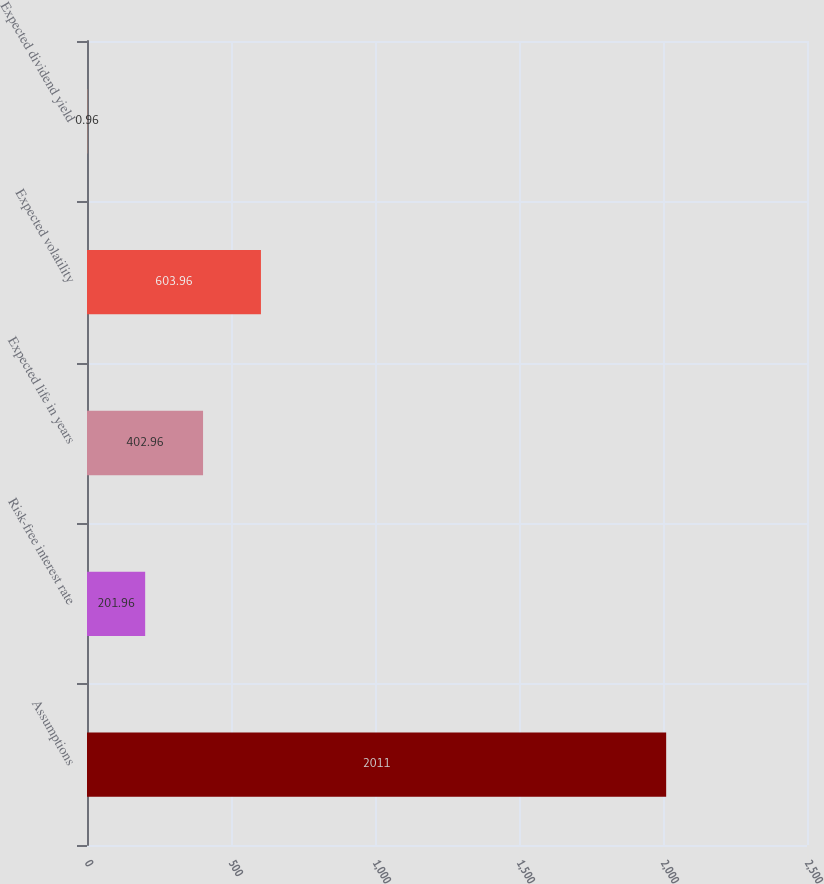<chart> <loc_0><loc_0><loc_500><loc_500><bar_chart><fcel>Assumptions<fcel>Risk-free interest rate<fcel>Expected life in years<fcel>Expected volatility<fcel>Expected dividend yield<nl><fcel>2011<fcel>201.96<fcel>402.96<fcel>603.96<fcel>0.96<nl></chart> 